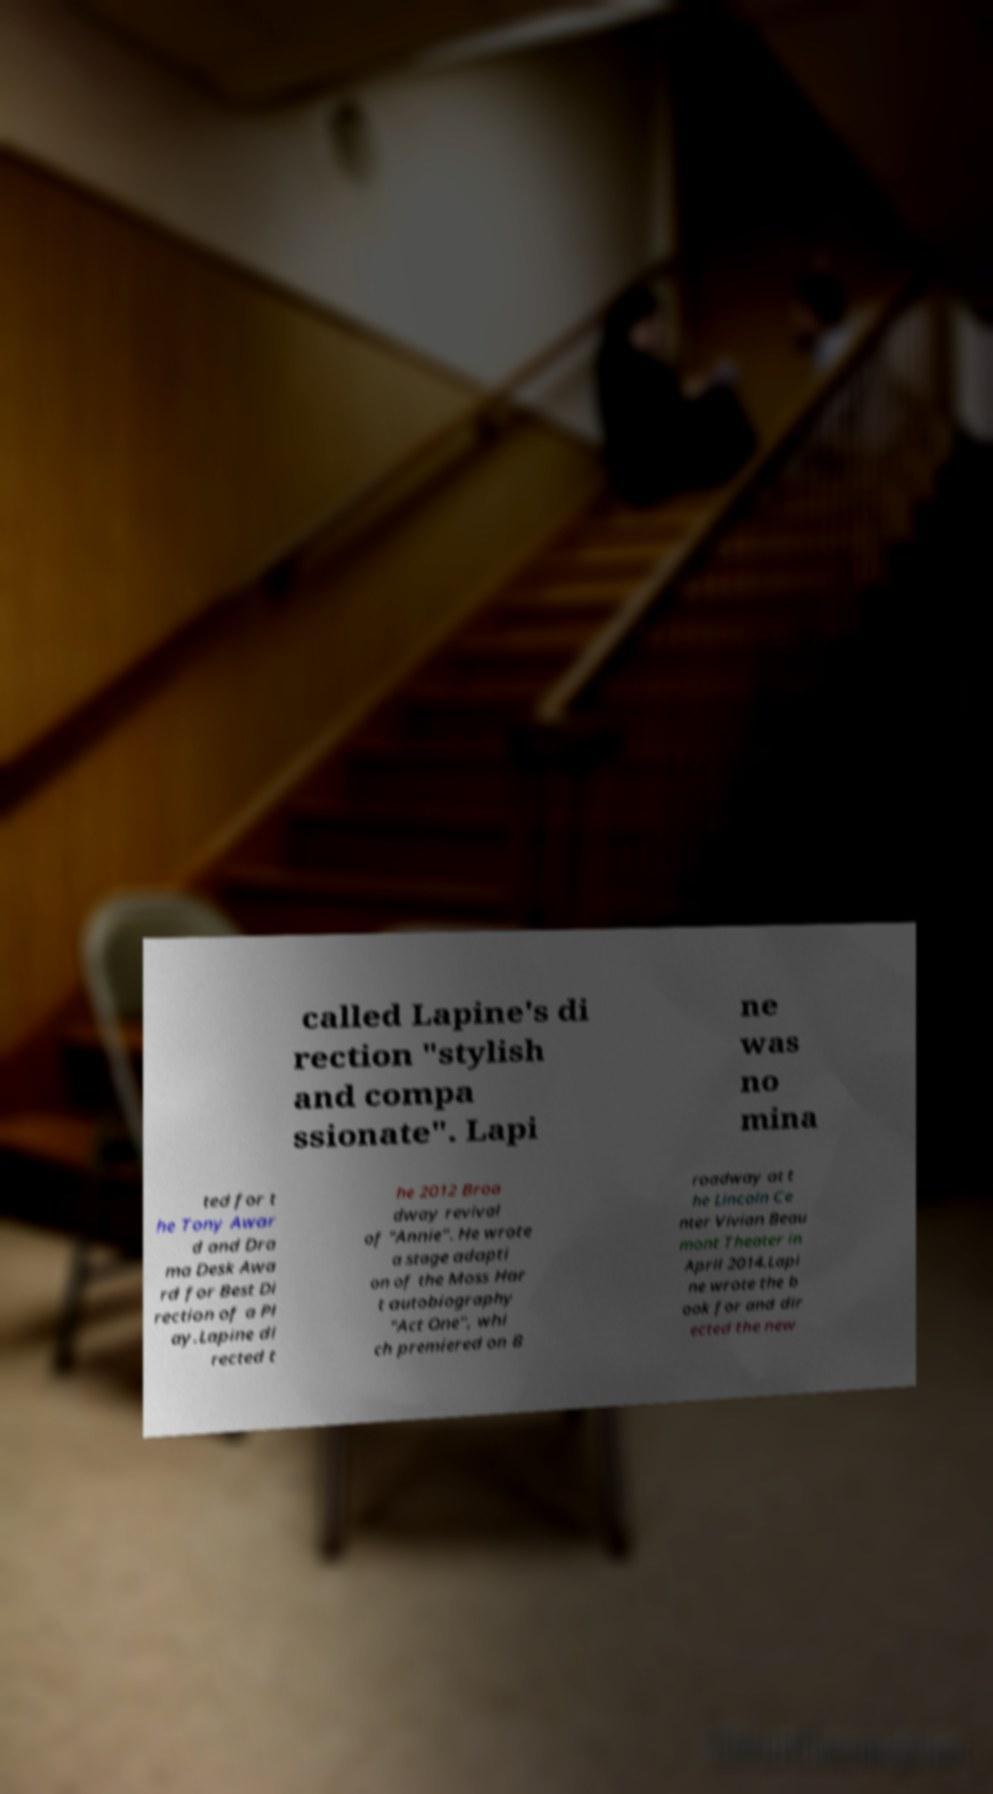There's text embedded in this image that I need extracted. Can you transcribe it verbatim? called Lapine's di rection "stylish and compa ssionate". Lapi ne was no mina ted for t he Tony Awar d and Dra ma Desk Awa rd for Best Di rection of a Pl ay.Lapine di rected t he 2012 Broa dway revival of "Annie". He wrote a stage adapti on of the Moss Har t autobiography "Act One", whi ch premiered on B roadway at t he Lincoln Ce nter Vivian Beau mont Theater in April 2014.Lapi ne wrote the b ook for and dir ected the new 